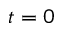Convert formula to latex. <formula><loc_0><loc_0><loc_500><loc_500>t = 0</formula> 